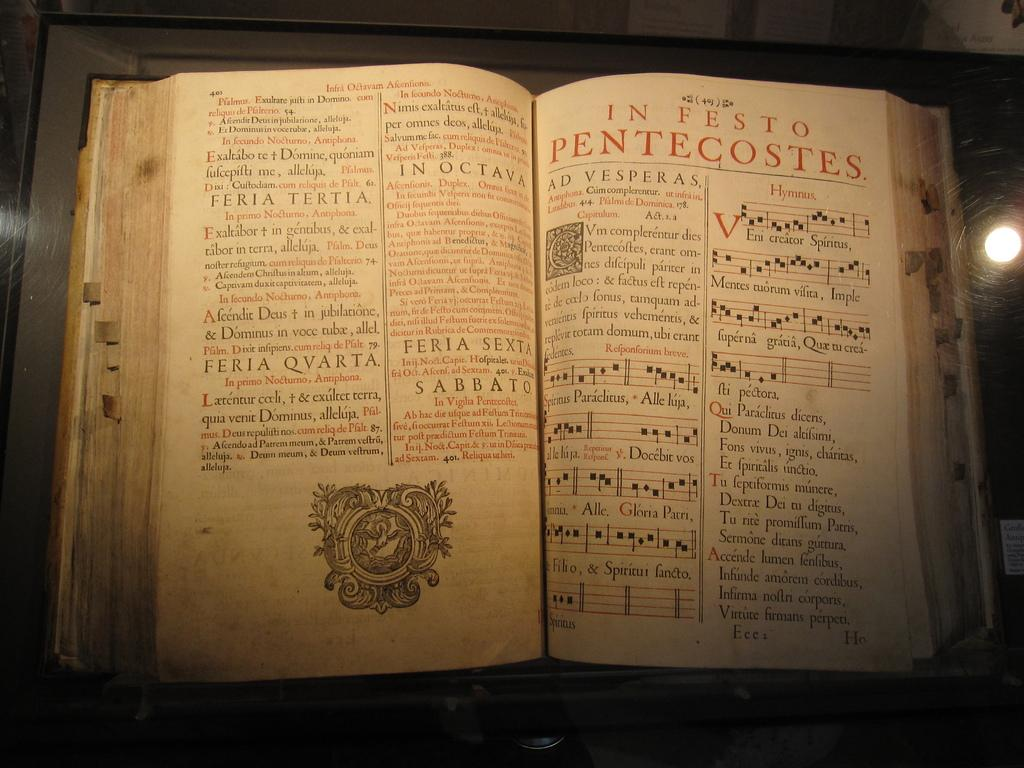<image>
Write a terse but informative summary of the picture. A large, old book open to a page that reads, "In Festo Pentecostes". 